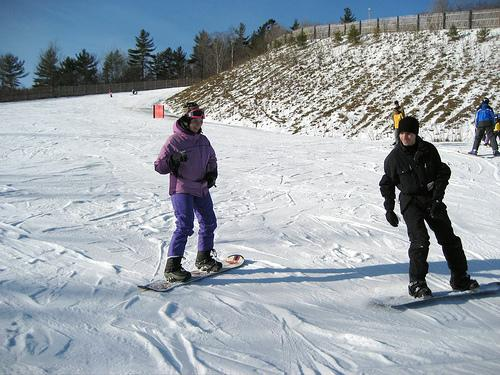What additional objects or elements are present in the image besides the snowboarders? Besides the snowboarders, there's white snow, grass on the hill, green vegetation, a fence on the top of the hill, various shades, and a clear blue sky. How many trees are partially visible near the top of the slope? There are multiple small trees partially visible near the top of the slope. Assess the quality of the image in terms of sharpness, brightness, and contrast. The image has good sharpness, brightness, and contrast, with clearly visible details and well-defined subjects. How many snowboarders are there in the image and what are they wearing? There are 2 snowboarders, one woman in a purple jacket and blue pants, and one man dressed in all black. What is the general emotion or sentiment conveyed by the scene in the image? The scene conveys excitement and adventure as the snowboarders enjoy winter sports. Identify the colors of the jackets worn by the snowboarders in the image. The woman wears a pale purple jacket and the man wears a black jacket. Describe the clothing the woman snowboarder is wearing in detail. The woman is wearing a pale purple jacket, blue pants, red goggles on her forehead, and black boots with a snowboard under her feet. Analyze the interaction between the snowboarders and their environment. The snowboarders are on a slope covered with snow and small trees, with a hill in the background, implying they are engaging in a winter sport activity. Examine the background of the image and list the prominent natural elements present. In the background, there are trees in distance, green trees, a clear blue sky, snow on the ground, and a rise in ground behind the snowboarders. Provide a brief caption summarizing the main content of the image. Snowboarders on a slope, with a woman in a purple jacket and a man dressed in black, surrounded by trees and snowy landscape. 